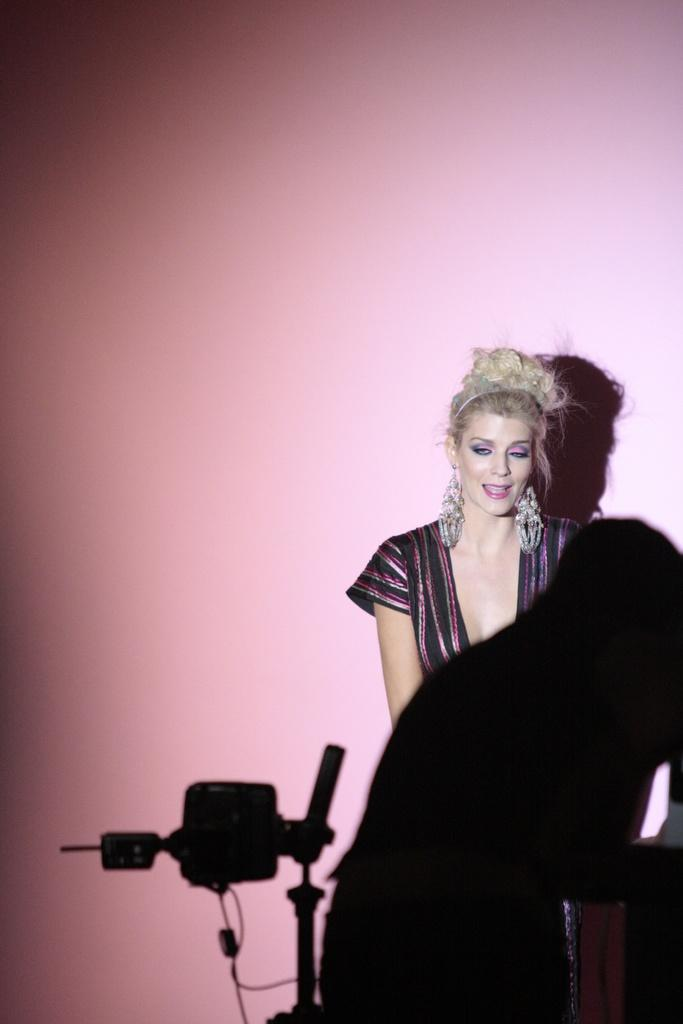What is the gender of the person in the image? The person in the image is a woman. Can you describe the pink object in the image? There is a pink object in the image, but its specific details are not mentioned in the facts. How many people are present in the image? There is one person present in the image, a woman. What type of ghost can be seen interacting with the pink object in the image? There is no ghost present in the image, and therefore no such interaction can be observed. 